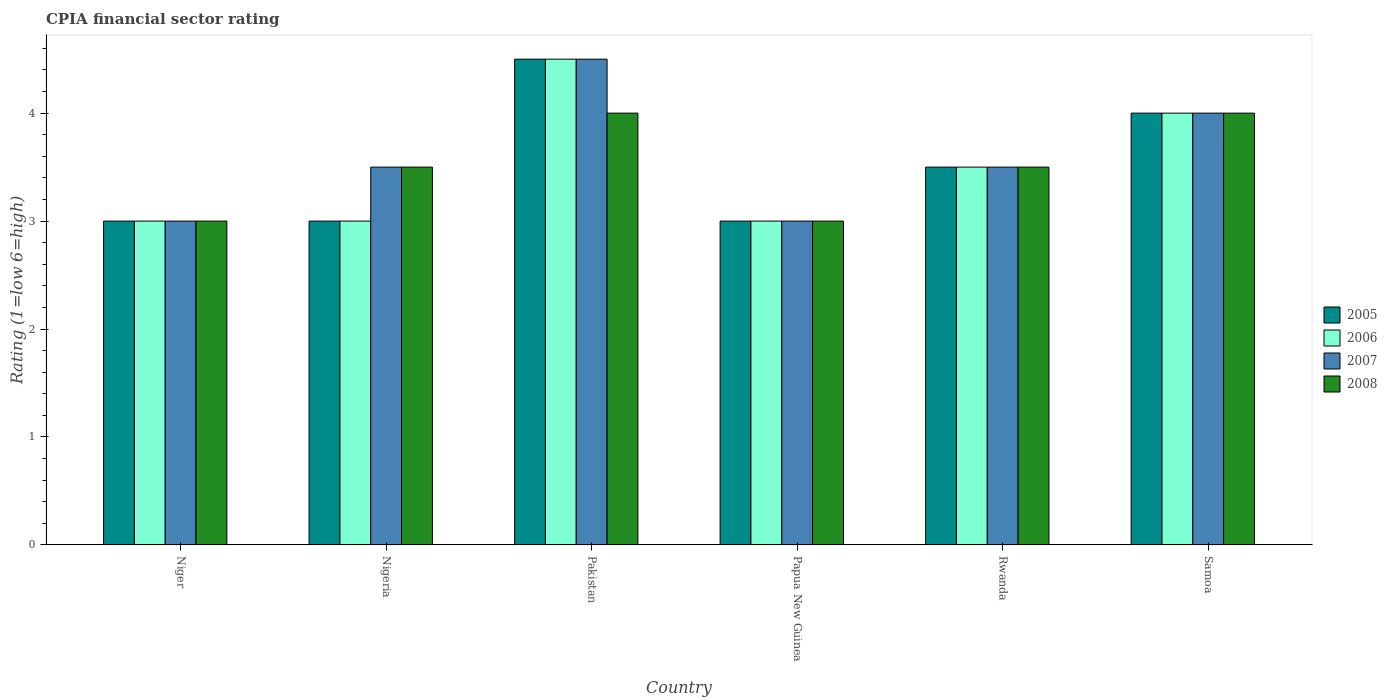How many groups of bars are there?
Keep it short and to the point. 6. Are the number of bars per tick equal to the number of legend labels?
Give a very brief answer. Yes. What is the label of the 3rd group of bars from the left?
Offer a very short reply. Pakistan. What is the CPIA rating in 2007 in Niger?
Give a very brief answer. 3. Across all countries, what is the maximum CPIA rating in 2008?
Keep it short and to the point. 4. Across all countries, what is the minimum CPIA rating in 2006?
Your answer should be very brief. 3. In which country was the CPIA rating in 2005 minimum?
Ensure brevity in your answer.  Niger. What is the difference between the CPIA rating in 2005 in Nigeria and that in Papua New Guinea?
Your response must be concise. 0. What is the difference between the CPIA rating of/in 2006 and CPIA rating of/in 2008 in Niger?
Your answer should be compact. 0. Is the CPIA rating in 2008 in Niger less than that in Pakistan?
Give a very brief answer. Yes. Is the difference between the CPIA rating in 2006 in Niger and Papua New Guinea greater than the difference between the CPIA rating in 2008 in Niger and Papua New Guinea?
Your response must be concise. No. In how many countries, is the CPIA rating in 2008 greater than the average CPIA rating in 2008 taken over all countries?
Give a very brief answer. 2. Is the sum of the CPIA rating in 2006 in Niger and Samoa greater than the maximum CPIA rating in 2005 across all countries?
Give a very brief answer. Yes. Is it the case that in every country, the sum of the CPIA rating in 2008 and CPIA rating in 2006 is greater than the sum of CPIA rating in 2005 and CPIA rating in 2007?
Your answer should be compact. No. What does the 3rd bar from the left in Nigeria represents?
Provide a short and direct response. 2007. Is it the case that in every country, the sum of the CPIA rating in 2005 and CPIA rating in 2006 is greater than the CPIA rating in 2008?
Ensure brevity in your answer.  Yes. How many bars are there?
Your response must be concise. 24. Are all the bars in the graph horizontal?
Ensure brevity in your answer.  No. How many countries are there in the graph?
Your answer should be very brief. 6. Are the values on the major ticks of Y-axis written in scientific E-notation?
Keep it short and to the point. No. Where does the legend appear in the graph?
Ensure brevity in your answer.  Center right. How many legend labels are there?
Make the answer very short. 4. How are the legend labels stacked?
Offer a terse response. Vertical. What is the title of the graph?
Your answer should be very brief. CPIA financial sector rating. Does "1971" appear as one of the legend labels in the graph?
Your answer should be compact. No. What is the label or title of the X-axis?
Your answer should be very brief. Country. What is the label or title of the Y-axis?
Keep it short and to the point. Rating (1=low 6=high). What is the Rating (1=low 6=high) of 2005 in Niger?
Offer a very short reply. 3. What is the Rating (1=low 6=high) in 2007 in Niger?
Give a very brief answer. 3. What is the Rating (1=low 6=high) of 2005 in Nigeria?
Your response must be concise. 3. What is the Rating (1=low 6=high) of 2006 in Nigeria?
Your response must be concise. 3. What is the Rating (1=low 6=high) in 2008 in Nigeria?
Give a very brief answer. 3.5. What is the Rating (1=low 6=high) of 2006 in Pakistan?
Offer a terse response. 4.5. What is the Rating (1=low 6=high) of 2007 in Pakistan?
Provide a succinct answer. 4.5. What is the Rating (1=low 6=high) of 2005 in Papua New Guinea?
Give a very brief answer. 3. What is the Rating (1=low 6=high) in 2006 in Papua New Guinea?
Keep it short and to the point. 3. What is the Rating (1=low 6=high) of 2005 in Samoa?
Your answer should be compact. 4. What is the Rating (1=low 6=high) in 2007 in Samoa?
Offer a very short reply. 4. Across all countries, what is the maximum Rating (1=low 6=high) of 2008?
Make the answer very short. 4. Across all countries, what is the minimum Rating (1=low 6=high) in 2006?
Make the answer very short. 3. Across all countries, what is the minimum Rating (1=low 6=high) in 2007?
Provide a short and direct response. 3. Across all countries, what is the minimum Rating (1=low 6=high) in 2008?
Give a very brief answer. 3. What is the total Rating (1=low 6=high) of 2006 in the graph?
Offer a very short reply. 21. What is the total Rating (1=low 6=high) in 2007 in the graph?
Give a very brief answer. 21.5. What is the difference between the Rating (1=low 6=high) in 2005 in Niger and that in Nigeria?
Provide a short and direct response. 0. What is the difference between the Rating (1=low 6=high) in 2007 in Niger and that in Nigeria?
Your response must be concise. -0.5. What is the difference between the Rating (1=low 6=high) of 2008 in Niger and that in Nigeria?
Give a very brief answer. -0.5. What is the difference between the Rating (1=low 6=high) of 2005 in Niger and that in Pakistan?
Offer a terse response. -1.5. What is the difference between the Rating (1=low 6=high) in 2005 in Niger and that in Papua New Guinea?
Keep it short and to the point. 0. What is the difference between the Rating (1=low 6=high) of 2008 in Niger and that in Papua New Guinea?
Keep it short and to the point. 0. What is the difference between the Rating (1=low 6=high) in 2007 in Niger and that in Rwanda?
Make the answer very short. -0.5. What is the difference between the Rating (1=low 6=high) in 2008 in Niger and that in Rwanda?
Give a very brief answer. -0.5. What is the difference between the Rating (1=low 6=high) in 2005 in Niger and that in Samoa?
Provide a short and direct response. -1. What is the difference between the Rating (1=low 6=high) in 2006 in Niger and that in Samoa?
Provide a short and direct response. -1. What is the difference between the Rating (1=low 6=high) in 2008 in Niger and that in Samoa?
Your answer should be very brief. -1. What is the difference between the Rating (1=low 6=high) of 2007 in Nigeria and that in Pakistan?
Offer a terse response. -1. What is the difference between the Rating (1=low 6=high) of 2005 in Nigeria and that in Papua New Guinea?
Offer a very short reply. 0. What is the difference between the Rating (1=low 6=high) in 2006 in Nigeria and that in Papua New Guinea?
Offer a very short reply. 0. What is the difference between the Rating (1=low 6=high) in 2008 in Nigeria and that in Papua New Guinea?
Provide a short and direct response. 0.5. What is the difference between the Rating (1=low 6=high) in 2006 in Nigeria and that in Rwanda?
Offer a very short reply. -0.5. What is the difference between the Rating (1=low 6=high) of 2007 in Nigeria and that in Rwanda?
Your answer should be very brief. 0. What is the difference between the Rating (1=low 6=high) in 2008 in Nigeria and that in Rwanda?
Offer a very short reply. 0. What is the difference between the Rating (1=low 6=high) in 2007 in Nigeria and that in Samoa?
Your answer should be compact. -0.5. What is the difference between the Rating (1=low 6=high) of 2005 in Pakistan and that in Papua New Guinea?
Give a very brief answer. 1.5. What is the difference between the Rating (1=low 6=high) of 2006 in Pakistan and that in Papua New Guinea?
Offer a terse response. 1.5. What is the difference between the Rating (1=low 6=high) in 2008 in Pakistan and that in Rwanda?
Your answer should be very brief. 0.5. What is the difference between the Rating (1=low 6=high) of 2006 in Pakistan and that in Samoa?
Give a very brief answer. 0.5. What is the difference between the Rating (1=low 6=high) in 2007 in Pakistan and that in Samoa?
Your answer should be very brief. 0.5. What is the difference between the Rating (1=low 6=high) of 2008 in Pakistan and that in Samoa?
Ensure brevity in your answer.  0. What is the difference between the Rating (1=low 6=high) of 2006 in Papua New Guinea and that in Rwanda?
Make the answer very short. -0.5. What is the difference between the Rating (1=low 6=high) in 2006 in Papua New Guinea and that in Samoa?
Ensure brevity in your answer.  -1. What is the difference between the Rating (1=low 6=high) in 2008 in Papua New Guinea and that in Samoa?
Your answer should be compact. -1. What is the difference between the Rating (1=low 6=high) of 2005 in Rwanda and that in Samoa?
Your answer should be very brief. -0.5. What is the difference between the Rating (1=low 6=high) in 2006 in Rwanda and that in Samoa?
Give a very brief answer. -0.5. What is the difference between the Rating (1=low 6=high) of 2008 in Rwanda and that in Samoa?
Keep it short and to the point. -0.5. What is the difference between the Rating (1=low 6=high) of 2005 in Niger and the Rating (1=low 6=high) of 2006 in Nigeria?
Your answer should be very brief. 0. What is the difference between the Rating (1=low 6=high) of 2006 in Niger and the Rating (1=low 6=high) of 2007 in Nigeria?
Ensure brevity in your answer.  -0.5. What is the difference between the Rating (1=low 6=high) in 2007 in Niger and the Rating (1=low 6=high) in 2008 in Nigeria?
Provide a succinct answer. -0.5. What is the difference between the Rating (1=low 6=high) in 2005 in Niger and the Rating (1=low 6=high) in 2008 in Pakistan?
Your response must be concise. -1. What is the difference between the Rating (1=low 6=high) in 2005 in Niger and the Rating (1=low 6=high) in 2006 in Papua New Guinea?
Give a very brief answer. 0. What is the difference between the Rating (1=low 6=high) in 2005 in Niger and the Rating (1=low 6=high) in 2007 in Papua New Guinea?
Provide a succinct answer. 0. What is the difference between the Rating (1=low 6=high) of 2005 in Niger and the Rating (1=low 6=high) of 2008 in Papua New Guinea?
Your response must be concise. 0. What is the difference between the Rating (1=low 6=high) in 2007 in Niger and the Rating (1=low 6=high) in 2008 in Papua New Guinea?
Provide a short and direct response. 0. What is the difference between the Rating (1=low 6=high) of 2005 in Niger and the Rating (1=low 6=high) of 2006 in Rwanda?
Your answer should be very brief. -0.5. What is the difference between the Rating (1=low 6=high) in 2005 in Niger and the Rating (1=low 6=high) in 2008 in Rwanda?
Offer a terse response. -0.5. What is the difference between the Rating (1=low 6=high) in 2006 in Niger and the Rating (1=low 6=high) in 2007 in Rwanda?
Offer a terse response. -0.5. What is the difference between the Rating (1=low 6=high) in 2005 in Niger and the Rating (1=low 6=high) in 2006 in Samoa?
Your response must be concise. -1. What is the difference between the Rating (1=low 6=high) in 2007 in Niger and the Rating (1=low 6=high) in 2008 in Samoa?
Your answer should be very brief. -1. What is the difference between the Rating (1=low 6=high) in 2005 in Nigeria and the Rating (1=low 6=high) in 2007 in Pakistan?
Give a very brief answer. -1.5. What is the difference between the Rating (1=low 6=high) of 2005 in Nigeria and the Rating (1=low 6=high) of 2008 in Pakistan?
Your answer should be very brief. -1. What is the difference between the Rating (1=low 6=high) of 2007 in Nigeria and the Rating (1=low 6=high) of 2008 in Pakistan?
Your answer should be compact. -0.5. What is the difference between the Rating (1=low 6=high) of 2005 in Nigeria and the Rating (1=low 6=high) of 2006 in Papua New Guinea?
Make the answer very short. 0. What is the difference between the Rating (1=low 6=high) of 2005 in Nigeria and the Rating (1=low 6=high) of 2007 in Papua New Guinea?
Your answer should be very brief. 0. What is the difference between the Rating (1=low 6=high) in 2005 in Nigeria and the Rating (1=low 6=high) in 2008 in Papua New Guinea?
Make the answer very short. 0. What is the difference between the Rating (1=low 6=high) in 2006 in Nigeria and the Rating (1=low 6=high) in 2008 in Papua New Guinea?
Your answer should be compact. 0. What is the difference between the Rating (1=low 6=high) of 2005 in Nigeria and the Rating (1=low 6=high) of 2008 in Rwanda?
Offer a terse response. -0.5. What is the difference between the Rating (1=low 6=high) in 2006 in Nigeria and the Rating (1=low 6=high) in 2007 in Samoa?
Make the answer very short. -1. What is the difference between the Rating (1=low 6=high) of 2006 in Nigeria and the Rating (1=low 6=high) of 2008 in Samoa?
Your answer should be compact. -1. What is the difference between the Rating (1=low 6=high) of 2005 in Pakistan and the Rating (1=low 6=high) of 2007 in Papua New Guinea?
Your answer should be very brief. 1.5. What is the difference between the Rating (1=low 6=high) of 2006 in Pakistan and the Rating (1=low 6=high) of 2007 in Papua New Guinea?
Provide a short and direct response. 1.5. What is the difference between the Rating (1=low 6=high) in 2005 in Pakistan and the Rating (1=low 6=high) in 2006 in Rwanda?
Your answer should be very brief. 1. What is the difference between the Rating (1=low 6=high) of 2005 in Pakistan and the Rating (1=low 6=high) of 2007 in Rwanda?
Provide a short and direct response. 1. What is the difference between the Rating (1=low 6=high) in 2005 in Pakistan and the Rating (1=low 6=high) in 2008 in Rwanda?
Ensure brevity in your answer.  1. What is the difference between the Rating (1=low 6=high) of 2005 in Pakistan and the Rating (1=low 6=high) of 2006 in Samoa?
Make the answer very short. 0.5. What is the difference between the Rating (1=low 6=high) in 2005 in Pakistan and the Rating (1=low 6=high) in 2007 in Samoa?
Your answer should be very brief. 0.5. What is the difference between the Rating (1=low 6=high) of 2007 in Pakistan and the Rating (1=low 6=high) of 2008 in Samoa?
Offer a very short reply. 0.5. What is the difference between the Rating (1=low 6=high) of 2005 in Papua New Guinea and the Rating (1=low 6=high) of 2007 in Rwanda?
Offer a terse response. -0.5. What is the difference between the Rating (1=low 6=high) in 2006 in Papua New Guinea and the Rating (1=low 6=high) in 2008 in Rwanda?
Offer a very short reply. -0.5. What is the difference between the Rating (1=low 6=high) in 2007 in Papua New Guinea and the Rating (1=low 6=high) in 2008 in Rwanda?
Provide a succinct answer. -0.5. What is the difference between the Rating (1=low 6=high) in 2005 in Papua New Guinea and the Rating (1=low 6=high) in 2006 in Samoa?
Ensure brevity in your answer.  -1. What is the difference between the Rating (1=low 6=high) in 2005 in Papua New Guinea and the Rating (1=low 6=high) in 2008 in Samoa?
Keep it short and to the point. -1. What is the difference between the Rating (1=low 6=high) in 2007 in Papua New Guinea and the Rating (1=low 6=high) in 2008 in Samoa?
Offer a very short reply. -1. What is the difference between the Rating (1=low 6=high) in 2005 in Rwanda and the Rating (1=low 6=high) in 2006 in Samoa?
Offer a terse response. -0.5. What is the difference between the Rating (1=low 6=high) in 2005 in Rwanda and the Rating (1=low 6=high) in 2008 in Samoa?
Offer a very short reply. -0.5. What is the difference between the Rating (1=low 6=high) in 2006 in Rwanda and the Rating (1=low 6=high) in 2007 in Samoa?
Offer a very short reply. -0.5. What is the difference between the Rating (1=low 6=high) of 2006 in Rwanda and the Rating (1=low 6=high) of 2008 in Samoa?
Make the answer very short. -0.5. What is the difference between the Rating (1=low 6=high) of 2007 in Rwanda and the Rating (1=low 6=high) of 2008 in Samoa?
Give a very brief answer. -0.5. What is the average Rating (1=low 6=high) of 2006 per country?
Your response must be concise. 3.5. What is the average Rating (1=low 6=high) in 2007 per country?
Your answer should be very brief. 3.58. What is the average Rating (1=low 6=high) in 2008 per country?
Your response must be concise. 3.5. What is the difference between the Rating (1=low 6=high) of 2006 and Rating (1=low 6=high) of 2007 in Niger?
Keep it short and to the point. 0. What is the difference between the Rating (1=low 6=high) in 2006 and Rating (1=low 6=high) in 2008 in Niger?
Offer a terse response. 0. What is the difference between the Rating (1=low 6=high) of 2007 and Rating (1=low 6=high) of 2008 in Niger?
Provide a succinct answer. 0. What is the difference between the Rating (1=low 6=high) of 2005 and Rating (1=low 6=high) of 2007 in Nigeria?
Your answer should be compact. -0.5. What is the difference between the Rating (1=low 6=high) of 2006 and Rating (1=low 6=high) of 2007 in Nigeria?
Offer a terse response. -0.5. What is the difference between the Rating (1=low 6=high) of 2006 and Rating (1=low 6=high) of 2008 in Nigeria?
Make the answer very short. -0.5. What is the difference between the Rating (1=low 6=high) in 2005 and Rating (1=low 6=high) in 2006 in Pakistan?
Provide a succinct answer. 0. What is the difference between the Rating (1=low 6=high) in 2005 and Rating (1=low 6=high) in 2006 in Papua New Guinea?
Keep it short and to the point. 0. What is the difference between the Rating (1=low 6=high) in 2005 and Rating (1=low 6=high) in 2008 in Papua New Guinea?
Provide a short and direct response. 0. What is the difference between the Rating (1=low 6=high) in 2007 and Rating (1=low 6=high) in 2008 in Papua New Guinea?
Keep it short and to the point. 0. What is the difference between the Rating (1=low 6=high) in 2006 and Rating (1=low 6=high) in 2007 in Rwanda?
Your answer should be compact. 0. What is the difference between the Rating (1=low 6=high) in 2006 and Rating (1=low 6=high) in 2008 in Samoa?
Provide a short and direct response. 0. What is the ratio of the Rating (1=low 6=high) of 2005 in Niger to that in Nigeria?
Provide a short and direct response. 1. What is the ratio of the Rating (1=low 6=high) in 2005 in Niger to that in Pakistan?
Your response must be concise. 0.67. What is the ratio of the Rating (1=low 6=high) of 2006 in Niger to that in Pakistan?
Keep it short and to the point. 0.67. What is the ratio of the Rating (1=low 6=high) of 2007 in Niger to that in Pakistan?
Your answer should be very brief. 0.67. What is the ratio of the Rating (1=low 6=high) of 2008 in Niger to that in Pakistan?
Give a very brief answer. 0.75. What is the ratio of the Rating (1=low 6=high) in 2005 in Niger to that in Papua New Guinea?
Your answer should be very brief. 1. What is the ratio of the Rating (1=low 6=high) of 2006 in Niger to that in Papua New Guinea?
Give a very brief answer. 1. What is the ratio of the Rating (1=low 6=high) in 2007 in Niger to that in Papua New Guinea?
Provide a short and direct response. 1. What is the ratio of the Rating (1=low 6=high) of 2005 in Niger to that in Rwanda?
Provide a succinct answer. 0.86. What is the ratio of the Rating (1=low 6=high) of 2006 in Niger to that in Rwanda?
Your response must be concise. 0.86. What is the ratio of the Rating (1=low 6=high) in 2006 in Niger to that in Samoa?
Offer a terse response. 0.75. What is the ratio of the Rating (1=low 6=high) in 2007 in Niger to that in Samoa?
Provide a short and direct response. 0.75. What is the ratio of the Rating (1=low 6=high) of 2005 in Nigeria to that in Pakistan?
Provide a short and direct response. 0.67. What is the ratio of the Rating (1=low 6=high) of 2006 in Nigeria to that in Pakistan?
Keep it short and to the point. 0.67. What is the ratio of the Rating (1=low 6=high) in 2005 in Nigeria to that in Papua New Guinea?
Your answer should be compact. 1. What is the ratio of the Rating (1=low 6=high) in 2006 in Nigeria to that in Papua New Guinea?
Keep it short and to the point. 1. What is the ratio of the Rating (1=low 6=high) of 2006 in Nigeria to that in Rwanda?
Give a very brief answer. 0.86. What is the ratio of the Rating (1=low 6=high) in 2007 in Nigeria to that in Rwanda?
Your response must be concise. 1. What is the ratio of the Rating (1=low 6=high) in 2005 in Nigeria to that in Samoa?
Provide a short and direct response. 0.75. What is the ratio of the Rating (1=low 6=high) in 2006 in Nigeria to that in Samoa?
Your answer should be compact. 0.75. What is the ratio of the Rating (1=low 6=high) in 2005 in Pakistan to that in Papua New Guinea?
Keep it short and to the point. 1.5. What is the ratio of the Rating (1=low 6=high) of 2007 in Pakistan to that in Papua New Guinea?
Ensure brevity in your answer.  1.5. What is the ratio of the Rating (1=low 6=high) of 2005 in Pakistan to that in Samoa?
Make the answer very short. 1.12. What is the ratio of the Rating (1=low 6=high) in 2006 in Pakistan to that in Samoa?
Give a very brief answer. 1.12. What is the ratio of the Rating (1=low 6=high) in 2007 in Pakistan to that in Samoa?
Ensure brevity in your answer.  1.12. What is the ratio of the Rating (1=low 6=high) of 2005 in Papua New Guinea to that in Rwanda?
Give a very brief answer. 0.86. What is the ratio of the Rating (1=low 6=high) of 2007 in Papua New Guinea to that in Rwanda?
Your response must be concise. 0.86. What is the ratio of the Rating (1=low 6=high) in 2006 in Papua New Guinea to that in Samoa?
Make the answer very short. 0.75. What is the ratio of the Rating (1=low 6=high) of 2007 in Papua New Guinea to that in Samoa?
Give a very brief answer. 0.75. What is the ratio of the Rating (1=low 6=high) in 2008 in Rwanda to that in Samoa?
Ensure brevity in your answer.  0.88. What is the difference between the highest and the second highest Rating (1=low 6=high) in 2006?
Your answer should be compact. 0.5. What is the difference between the highest and the second highest Rating (1=low 6=high) of 2007?
Offer a very short reply. 0.5. What is the difference between the highest and the second highest Rating (1=low 6=high) of 2008?
Give a very brief answer. 0. What is the difference between the highest and the lowest Rating (1=low 6=high) of 2007?
Provide a short and direct response. 1.5. What is the difference between the highest and the lowest Rating (1=low 6=high) of 2008?
Make the answer very short. 1. 